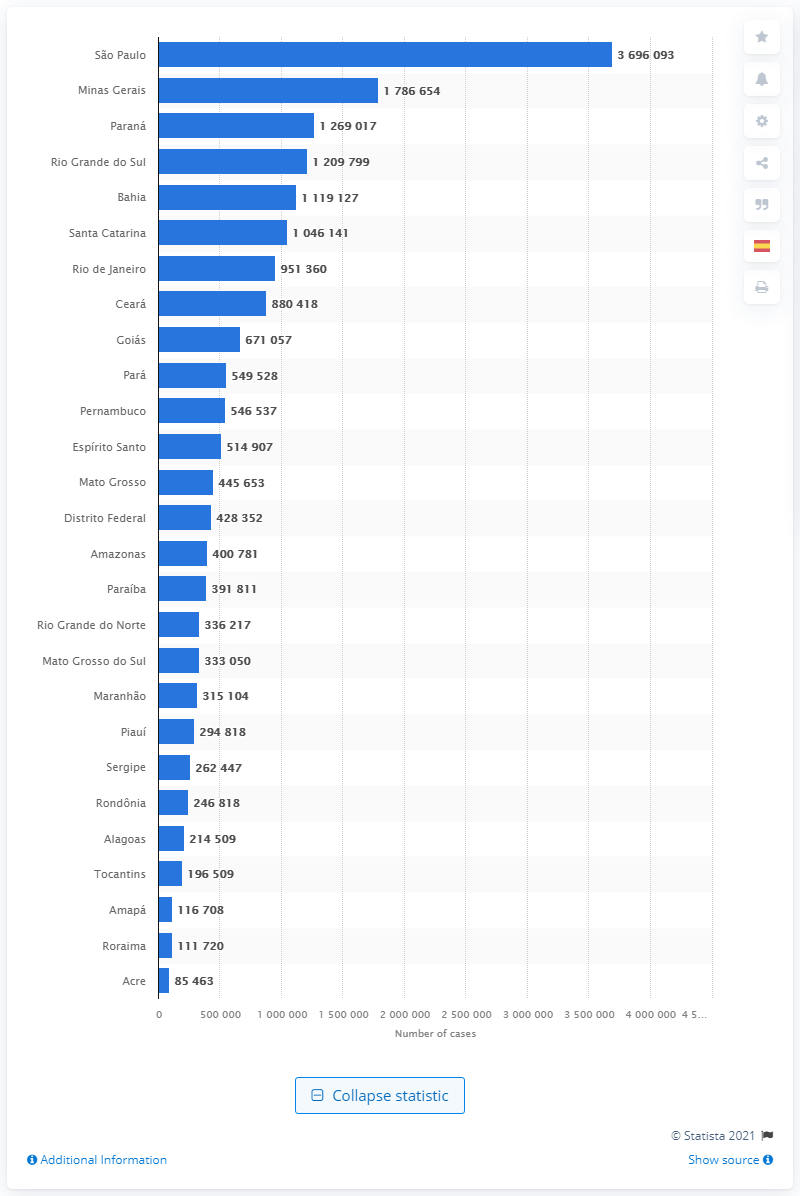Specify some key components in this picture. There were 369,6093 cases of COVID-19 in São Paulo. 